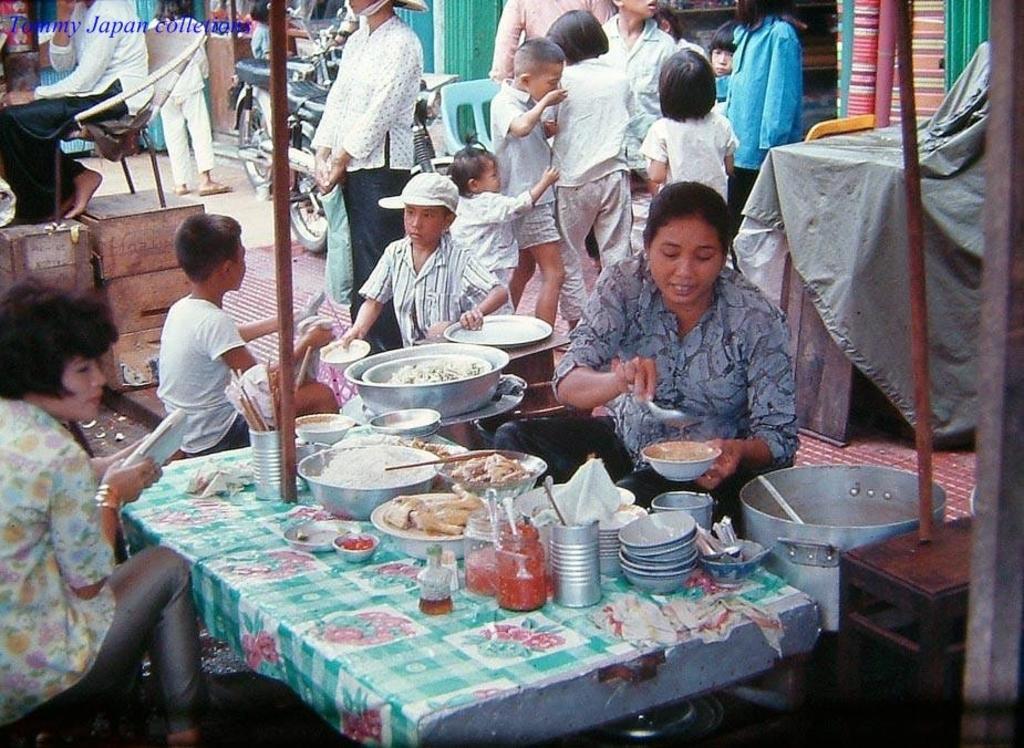In one or two sentences, can you explain what this image depicts? In the image there are two women sitting opposite side of table with food,bowls,vessels and glasses on it, in the back there are many kids and people standing on the footpath in front of stores. 